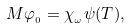Convert formula to latex. <formula><loc_0><loc_0><loc_500><loc_500>M \varphi _ { _ { 0 } } = \chi _ { _ { \omega } } \psi ( T ) ,</formula> 